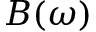Convert formula to latex. <formula><loc_0><loc_0><loc_500><loc_500>B ( \omega )</formula> 